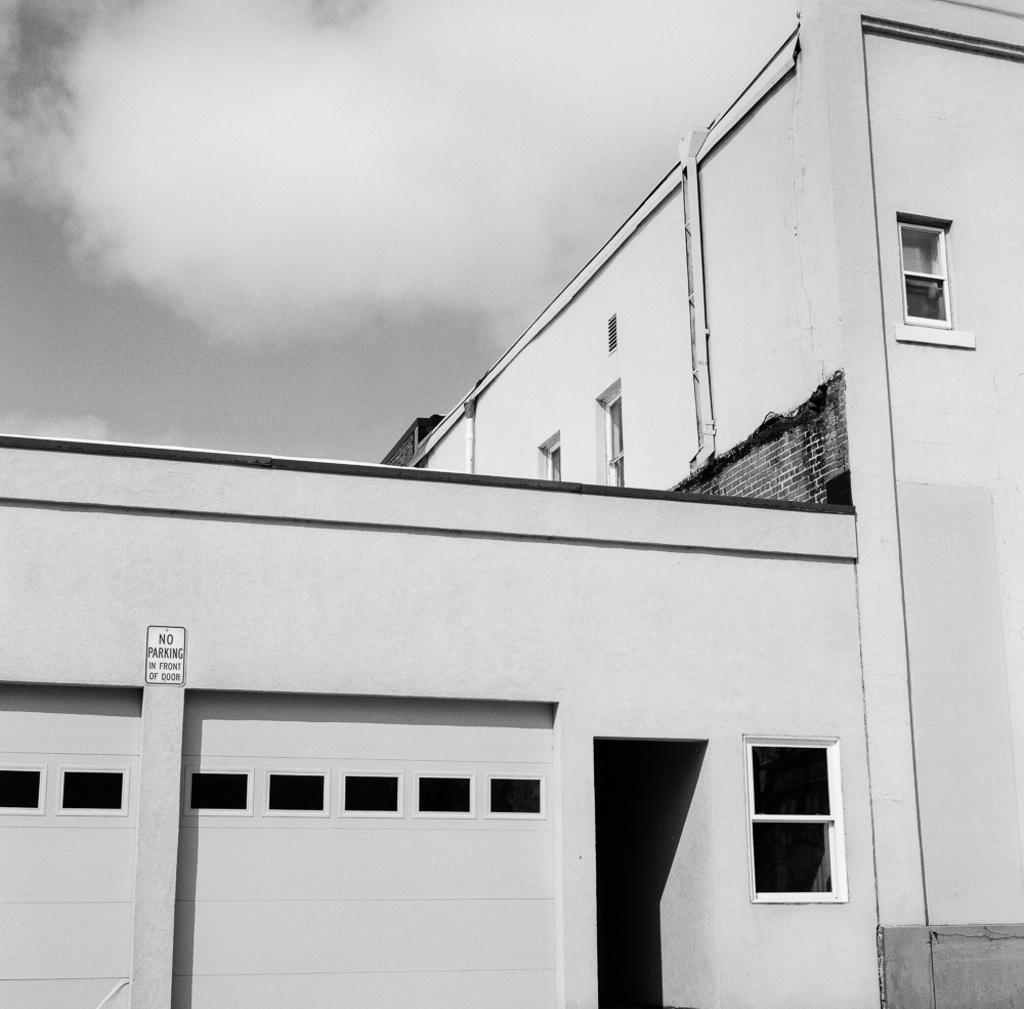What is the color scheme of the image? The image is black and white. What structure is present in the image? There is a building in the image. What feature can be seen on the building? The building has windows. What is visible in the background of the image? The sky is visible in the image. How would you describe the sky in the image? The sky appears cloudy. What type of lettuce can be seen growing on the bridge in the image? There is no bridge or lettuce present in the image; it features a black and white building with windows and a cloudy sky. 